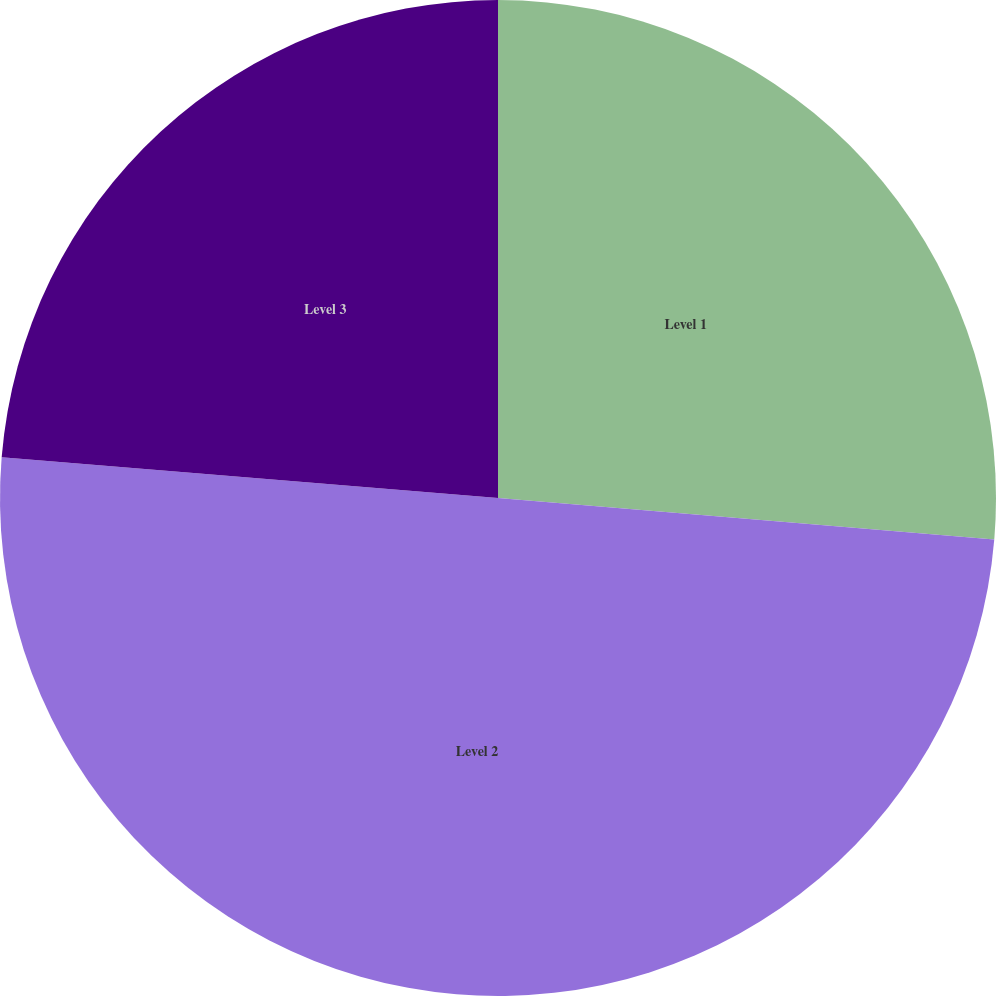<chart> <loc_0><loc_0><loc_500><loc_500><pie_chart><fcel>Level 1<fcel>Level 2<fcel>Level 3<nl><fcel>26.33%<fcel>49.97%<fcel>23.7%<nl></chart> 